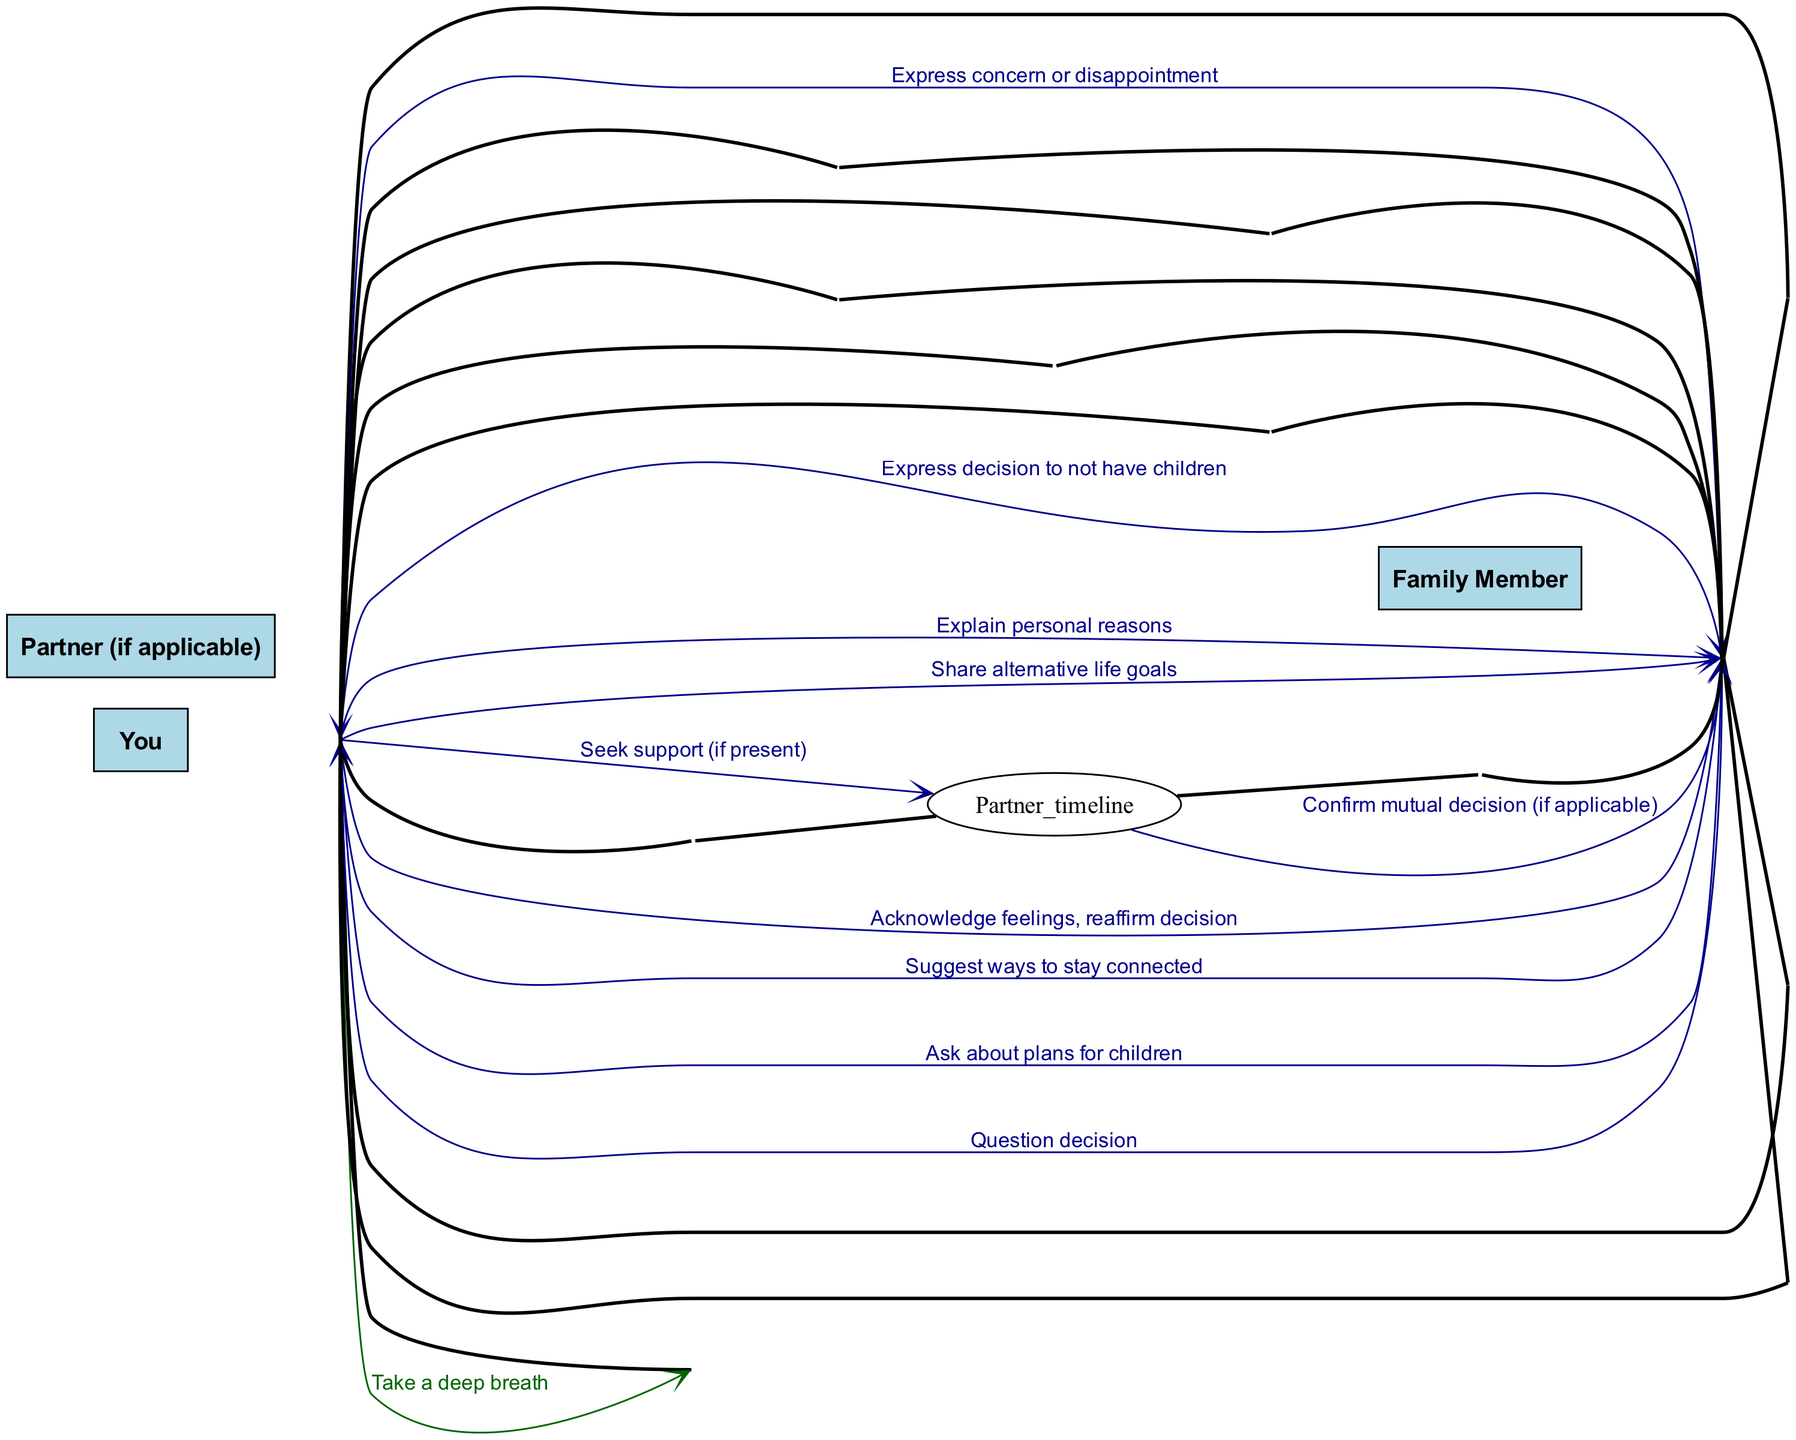What are the actors involved in the conversation? The actors listed in the diagram include "You," "Family Member," and "Partner (if applicable)." This can be found directly in the beginning section where the actors are defined.
Answer: You, Family Member, Partner (if applicable) How many total interactions does "You" have with others? "You" has five interactions with "Family Member" and one interaction with "Partner," totaling six interactions. By counting the number of lines connecting "You" to other actors (Family Member and Partner), we arrive at this total.
Answer: Six What is the second message exchanged in the sequence? The second message in the sequence is "Take a deep breath," which is exchanged from "You" to "You." By looking at the order of messages listed in the sequences, we can identify the second entry.
Answer: Take a deep breath Who questions the decision to not have children? The "Family Member" questions the decision, as indicated in the fourth message of the sequence where the Family Member directly asks about the decision. By examining the flow of interactions, we see that this is the actor who raises a question.
Answer: Family Member What type of support does "You" seek during the conversation? "You" seeks "support" from "Partner" (if applicable), as indicated by the message "Seek support (if present)." This is clearly shown in the fifth message of the interaction where "You" directly communicates with "Partner."
Answer: Support How does "You" react after being questioned about their decision? "You" explains their personal reasons following the questioning. This is represented in the sequence where "You" responds to the Family Member's question with the message "Explain personal reasons." This shows the response order in the conversation.
Answer: Explain personal reasons What alternative does "You" share to stay connected with the Family Member? "You" shares "alternative life goals." This is presented in the penultimate message from "You" to the "Family Member" where they discuss staying connected, reflecting on their own goals instead of having children.
Answer: Alternative life goals What does "Family Member" express after hearing about the decision? "Family Member" expresses "concern or disappointment." This is evident in the ninth message of the sequence to which the Family Member reacts after "You" shares insights about their decision.
Answer: Concern or disappointment 